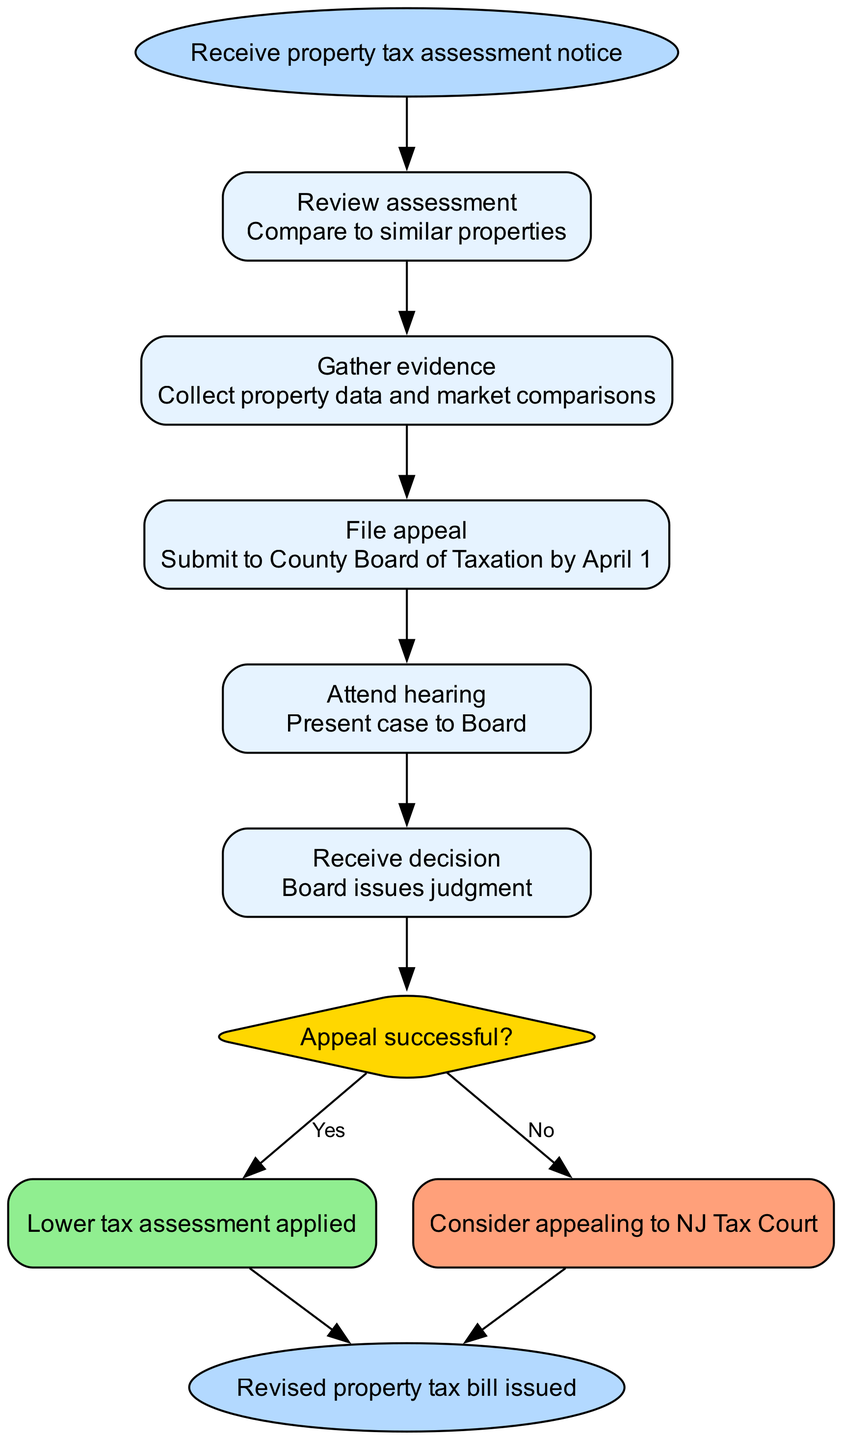What is the first step in the process? The first step is indicated directly after the "Receive property tax assessment notice" start node. It is labeled as "Review assessment."
Answer: Review assessment How many steps are there in total? There are five steps listed in the diagram, connecting from the start to the decision condition.
Answer: 5 What does the condition node represent? The condition node, labeled "Appeal successful?", presents a decision point in the process where the outcome of the appeal is determined.
Answer: Appeal successful? What happens if the appeal is unsuccessful? Following the "No" branch from the condition node, the outcome is described as "Consider appealing to NJ Tax Court."
Answer: Consider appealing to NJ Tax Court What is the final output of the process? The end node clearly states that the final outcome of the process is a "Revised property tax bill issued."
Answer: Revised property tax bill issued What connects the last step to the decision point? The last step, "Attend hearing," is directly connected to the condition node, indicating that it precedes the decision condition regarding the appeal's outcome.
Answer: Attend hearing If the appeal is successful, what action occurs next? If the decision is "Yes" at the condition node, it leads directly to the end node, where the output is the issuance of a revised bill.
Answer: Lower tax assessment applied What color represents the condition node in the diagram? The condition node is colored with a fill that is golden, indicating its decision nature.
Answer: Gold Which node follows the "File appeal" step? The node that follows "File appeal" is "Attend hearing," indicating the sequential flow of steps.
Answer: Attend hearing 